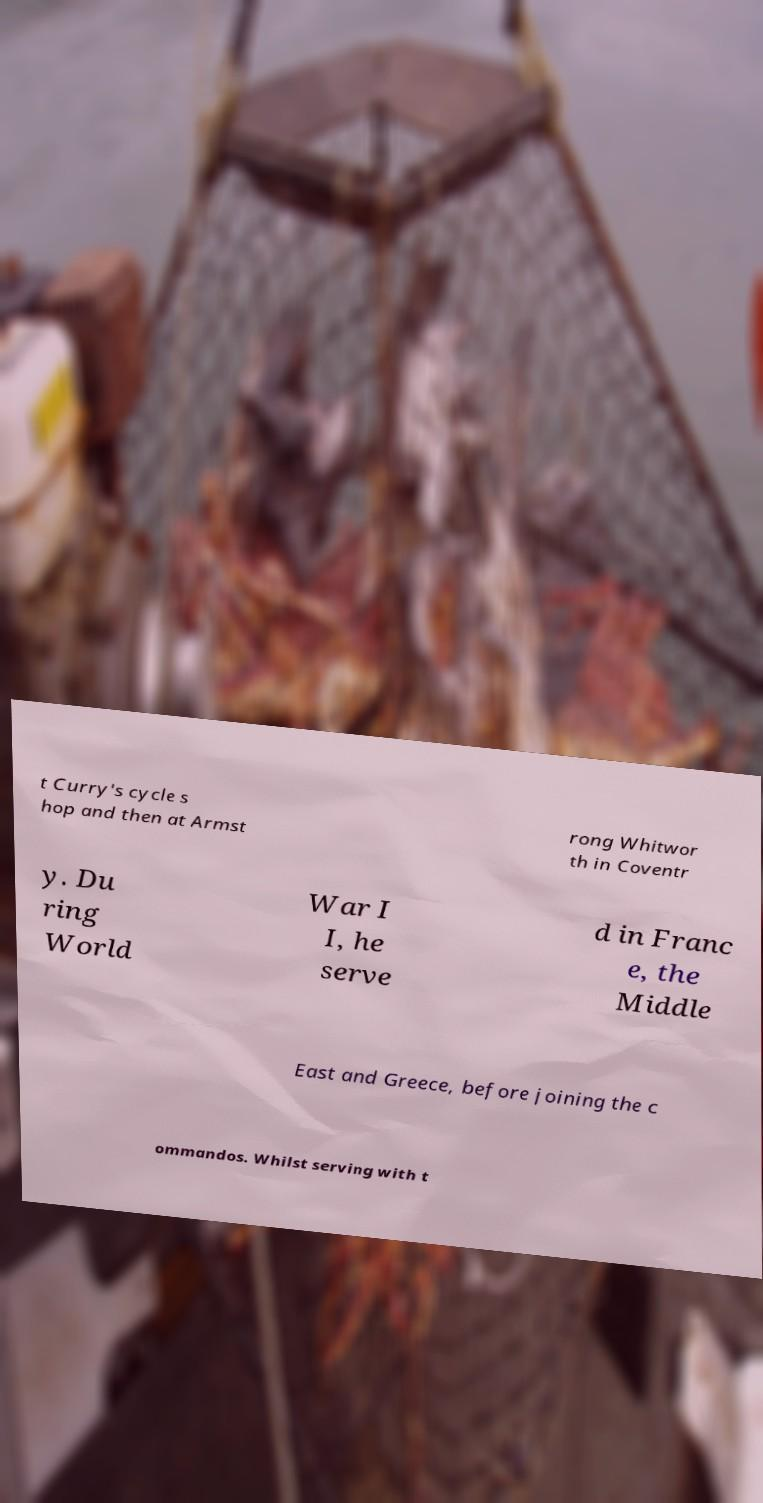Can you accurately transcribe the text from the provided image for me? t Curry's cycle s hop and then at Armst rong Whitwor th in Coventr y. Du ring World War I I, he serve d in Franc e, the Middle East and Greece, before joining the c ommandos. Whilst serving with t 